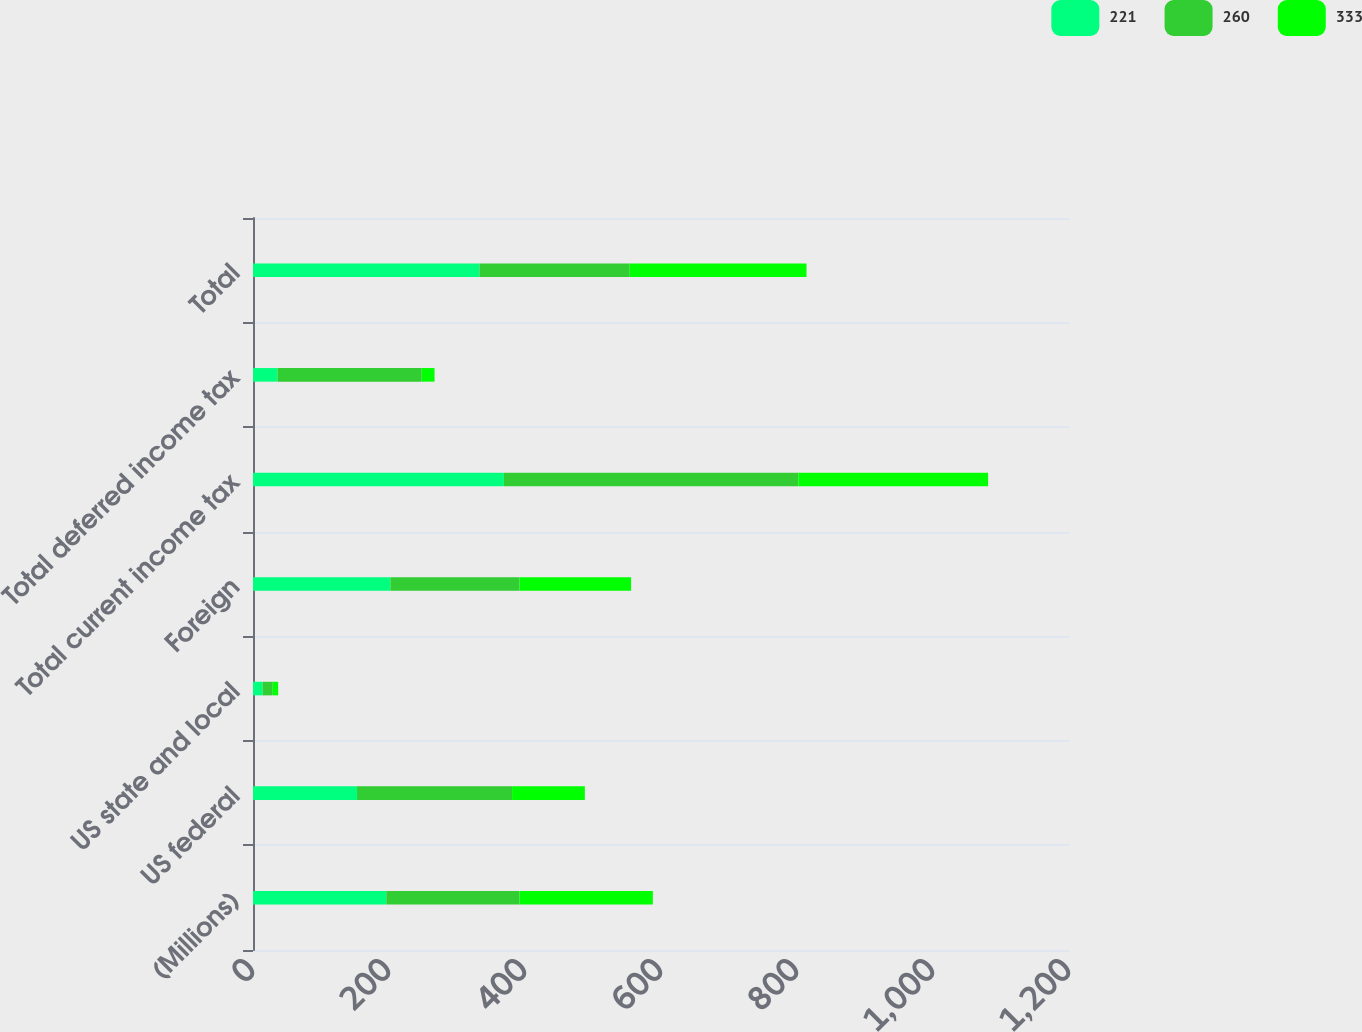<chart> <loc_0><loc_0><loc_500><loc_500><stacked_bar_chart><ecel><fcel>(Millions)<fcel>US federal<fcel>US state and local<fcel>Foreign<fcel>Total current income tax<fcel>Total deferred income tax<fcel>Total<nl><fcel>221<fcel>196<fcel>153<fcel>14<fcel>202<fcel>369<fcel>36<fcel>333<nl><fcel>260<fcel>196<fcel>228<fcel>15<fcel>190<fcel>433<fcel>212<fcel>221<nl><fcel>333<fcel>196<fcel>107<fcel>8<fcel>164<fcel>279<fcel>19<fcel>260<nl></chart> 